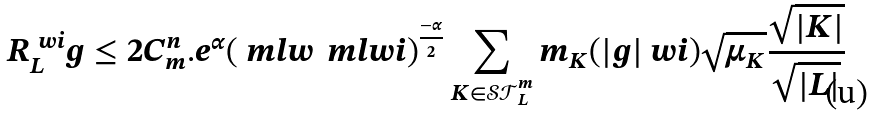<formula> <loc_0><loc_0><loc_500><loc_500>R ^ { \ w i } _ { L } g \leq 2 C ^ { n } _ { m } . e ^ { \alpha } ( \ m l w \, \ m l w i ) ^ { \frac { - \alpha } { 2 } } \sum _ { K \in \mathcal { S T } ^ { m } _ { L } } m _ { K } ( | g | \ w i ) \sqrt { \mu _ { K } } \frac { \sqrt { | K | } } { \sqrt { | L | } }</formula> 